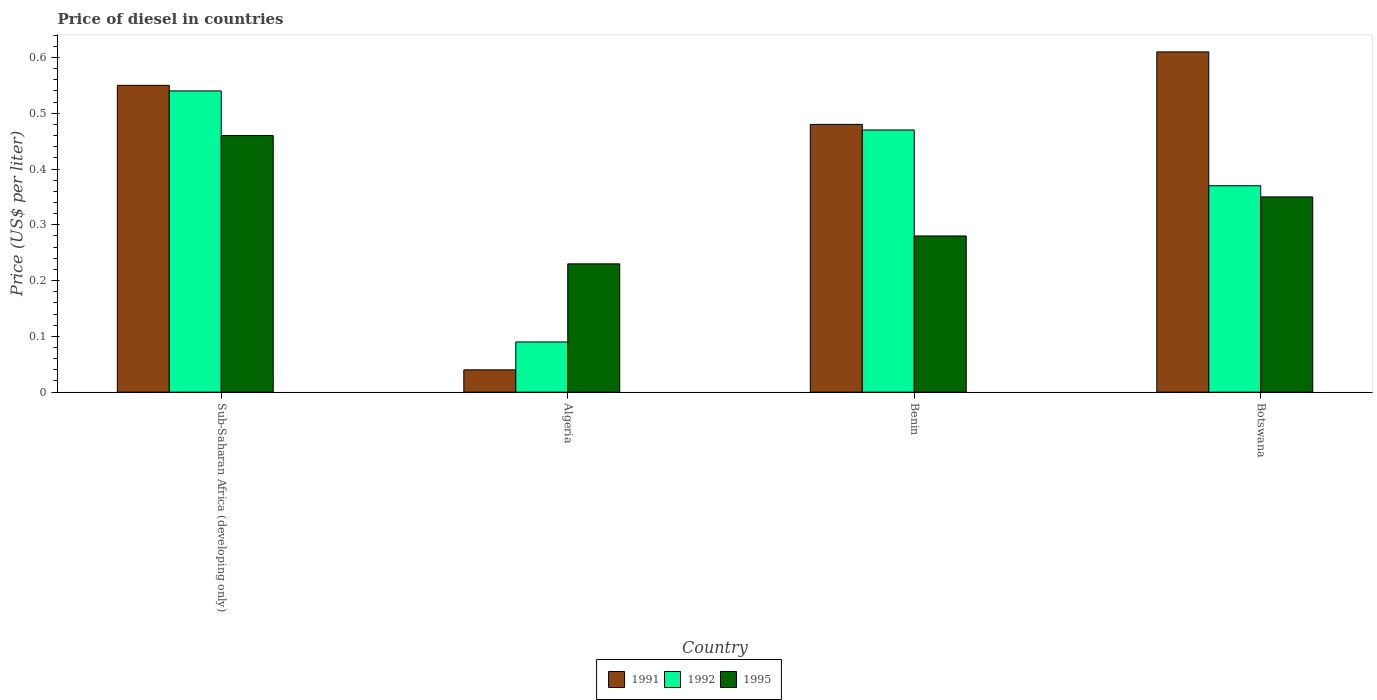How many groups of bars are there?
Ensure brevity in your answer.  4. Are the number of bars per tick equal to the number of legend labels?
Offer a terse response. Yes. Are the number of bars on each tick of the X-axis equal?
Your answer should be very brief. Yes. What is the label of the 2nd group of bars from the left?
Your response must be concise. Algeria. In how many cases, is the number of bars for a given country not equal to the number of legend labels?
Provide a succinct answer. 0. What is the price of diesel in 1992 in Sub-Saharan Africa (developing only)?
Your response must be concise. 0.54. Across all countries, what is the maximum price of diesel in 1991?
Your response must be concise. 0.61. In which country was the price of diesel in 1995 maximum?
Ensure brevity in your answer.  Sub-Saharan Africa (developing only). In which country was the price of diesel in 1992 minimum?
Offer a terse response. Algeria. What is the total price of diesel in 1991 in the graph?
Ensure brevity in your answer.  1.68. What is the difference between the price of diesel in 1992 in Algeria and that in Benin?
Make the answer very short. -0.38. What is the difference between the price of diesel in 1992 in Algeria and the price of diesel in 1991 in Sub-Saharan Africa (developing only)?
Offer a terse response. -0.46. What is the average price of diesel in 1991 per country?
Your answer should be compact. 0.42. What is the difference between the price of diesel of/in 1991 and price of diesel of/in 1992 in Sub-Saharan Africa (developing only)?
Provide a succinct answer. 0.01. What is the ratio of the price of diesel in 1991 in Algeria to that in Benin?
Your answer should be compact. 0.08. What is the difference between the highest and the second highest price of diesel in 1991?
Give a very brief answer. 0.06. What is the difference between the highest and the lowest price of diesel in 1992?
Offer a terse response. 0.45. Is the sum of the price of diesel in 1995 in Algeria and Benin greater than the maximum price of diesel in 1992 across all countries?
Keep it short and to the point. No. What does the 3rd bar from the left in Algeria represents?
Ensure brevity in your answer.  1995. What does the 2nd bar from the right in Botswana represents?
Keep it short and to the point. 1992. Is it the case that in every country, the sum of the price of diesel in 1991 and price of diesel in 1995 is greater than the price of diesel in 1992?
Keep it short and to the point. Yes. How many bars are there?
Make the answer very short. 12. Are all the bars in the graph horizontal?
Ensure brevity in your answer.  No. Are the values on the major ticks of Y-axis written in scientific E-notation?
Make the answer very short. No. Does the graph contain any zero values?
Provide a succinct answer. No. Does the graph contain grids?
Keep it short and to the point. No. Where does the legend appear in the graph?
Offer a very short reply. Bottom center. How many legend labels are there?
Ensure brevity in your answer.  3. What is the title of the graph?
Provide a short and direct response. Price of diesel in countries. Does "1998" appear as one of the legend labels in the graph?
Your response must be concise. No. What is the label or title of the X-axis?
Provide a short and direct response. Country. What is the label or title of the Y-axis?
Offer a very short reply. Price (US$ per liter). What is the Price (US$ per liter) of 1991 in Sub-Saharan Africa (developing only)?
Provide a short and direct response. 0.55. What is the Price (US$ per liter) of 1992 in Sub-Saharan Africa (developing only)?
Provide a short and direct response. 0.54. What is the Price (US$ per liter) of 1995 in Sub-Saharan Africa (developing only)?
Offer a terse response. 0.46. What is the Price (US$ per liter) in 1992 in Algeria?
Ensure brevity in your answer.  0.09. What is the Price (US$ per liter) of 1995 in Algeria?
Make the answer very short. 0.23. What is the Price (US$ per liter) in 1991 in Benin?
Ensure brevity in your answer.  0.48. What is the Price (US$ per liter) in 1992 in Benin?
Make the answer very short. 0.47. What is the Price (US$ per liter) in 1995 in Benin?
Provide a succinct answer. 0.28. What is the Price (US$ per liter) in 1991 in Botswana?
Ensure brevity in your answer.  0.61. What is the Price (US$ per liter) of 1992 in Botswana?
Your response must be concise. 0.37. What is the Price (US$ per liter) in 1995 in Botswana?
Your answer should be very brief. 0.35. Across all countries, what is the maximum Price (US$ per liter) of 1991?
Provide a short and direct response. 0.61. Across all countries, what is the maximum Price (US$ per liter) in 1992?
Your response must be concise. 0.54. Across all countries, what is the maximum Price (US$ per liter) of 1995?
Your answer should be compact. 0.46. Across all countries, what is the minimum Price (US$ per liter) in 1992?
Your answer should be very brief. 0.09. Across all countries, what is the minimum Price (US$ per liter) in 1995?
Keep it short and to the point. 0.23. What is the total Price (US$ per liter) of 1991 in the graph?
Keep it short and to the point. 1.68. What is the total Price (US$ per liter) in 1992 in the graph?
Give a very brief answer. 1.47. What is the total Price (US$ per liter) in 1995 in the graph?
Offer a terse response. 1.32. What is the difference between the Price (US$ per liter) of 1991 in Sub-Saharan Africa (developing only) and that in Algeria?
Give a very brief answer. 0.51. What is the difference between the Price (US$ per liter) of 1992 in Sub-Saharan Africa (developing only) and that in Algeria?
Provide a short and direct response. 0.45. What is the difference between the Price (US$ per liter) in 1995 in Sub-Saharan Africa (developing only) and that in Algeria?
Your response must be concise. 0.23. What is the difference between the Price (US$ per liter) in 1991 in Sub-Saharan Africa (developing only) and that in Benin?
Your response must be concise. 0.07. What is the difference between the Price (US$ per liter) of 1992 in Sub-Saharan Africa (developing only) and that in Benin?
Your answer should be compact. 0.07. What is the difference between the Price (US$ per liter) in 1995 in Sub-Saharan Africa (developing only) and that in Benin?
Your answer should be very brief. 0.18. What is the difference between the Price (US$ per liter) in 1991 in Sub-Saharan Africa (developing only) and that in Botswana?
Give a very brief answer. -0.06. What is the difference between the Price (US$ per liter) in 1992 in Sub-Saharan Africa (developing only) and that in Botswana?
Your response must be concise. 0.17. What is the difference between the Price (US$ per liter) of 1995 in Sub-Saharan Africa (developing only) and that in Botswana?
Ensure brevity in your answer.  0.11. What is the difference between the Price (US$ per liter) in 1991 in Algeria and that in Benin?
Ensure brevity in your answer.  -0.44. What is the difference between the Price (US$ per liter) in 1992 in Algeria and that in Benin?
Ensure brevity in your answer.  -0.38. What is the difference between the Price (US$ per liter) of 1995 in Algeria and that in Benin?
Keep it short and to the point. -0.05. What is the difference between the Price (US$ per liter) in 1991 in Algeria and that in Botswana?
Your response must be concise. -0.57. What is the difference between the Price (US$ per liter) of 1992 in Algeria and that in Botswana?
Ensure brevity in your answer.  -0.28. What is the difference between the Price (US$ per liter) in 1995 in Algeria and that in Botswana?
Provide a short and direct response. -0.12. What is the difference between the Price (US$ per liter) in 1991 in Benin and that in Botswana?
Your answer should be compact. -0.13. What is the difference between the Price (US$ per liter) in 1992 in Benin and that in Botswana?
Your response must be concise. 0.1. What is the difference between the Price (US$ per liter) in 1995 in Benin and that in Botswana?
Your answer should be very brief. -0.07. What is the difference between the Price (US$ per liter) in 1991 in Sub-Saharan Africa (developing only) and the Price (US$ per liter) in 1992 in Algeria?
Ensure brevity in your answer.  0.46. What is the difference between the Price (US$ per liter) of 1991 in Sub-Saharan Africa (developing only) and the Price (US$ per liter) of 1995 in Algeria?
Your response must be concise. 0.32. What is the difference between the Price (US$ per liter) in 1992 in Sub-Saharan Africa (developing only) and the Price (US$ per liter) in 1995 in Algeria?
Provide a short and direct response. 0.31. What is the difference between the Price (US$ per liter) in 1991 in Sub-Saharan Africa (developing only) and the Price (US$ per liter) in 1992 in Benin?
Your answer should be compact. 0.08. What is the difference between the Price (US$ per liter) of 1991 in Sub-Saharan Africa (developing only) and the Price (US$ per liter) of 1995 in Benin?
Offer a terse response. 0.27. What is the difference between the Price (US$ per liter) of 1992 in Sub-Saharan Africa (developing only) and the Price (US$ per liter) of 1995 in Benin?
Ensure brevity in your answer.  0.26. What is the difference between the Price (US$ per liter) in 1991 in Sub-Saharan Africa (developing only) and the Price (US$ per liter) in 1992 in Botswana?
Provide a succinct answer. 0.18. What is the difference between the Price (US$ per liter) of 1991 in Sub-Saharan Africa (developing only) and the Price (US$ per liter) of 1995 in Botswana?
Provide a succinct answer. 0.2. What is the difference between the Price (US$ per liter) of 1992 in Sub-Saharan Africa (developing only) and the Price (US$ per liter) of 1995 in Botswana?
Ensure brevity in your answer.  0.19. What is the difference between the Price (US$ per liter) in 1991 in Algeria and the Price (US$ per liter) in 1992 in Benin?
Your answer should be compact. -0.43. What is the difference between the Price (US$ per liter) of 1991 in Algeria and the Price (US$ per liter) of 1995 in Benin?
Ensure brevity in your answer.  -0.24. What is the difference between the Price (US$ per liter) in 1992 in Algeria and the Price (US$ per liter) in 1995 in Benin?
Give a very brief answer. -0.19. What is the difference between the Price (US$ per liter) in 1991 in Algeria and the Price (US$ per liter) in 1992 in Botswana?
Your answer should be compact. -0.33. What is the difference between the Price (US$ per liter) of 1991 in Algeria and the Price (US$ per liter) of 1995 in Botswana?
Provide a short and direct response. -0.31. What is the difference between the Price (US$ per liter) of 1992 in Algeria and the Price (US$ per liter) of 1995 in Botswana?
Provide a short and direct response. -0.26. What is the difference between the Price (US$ per liter) in 1991 in Benin and the Price (US$ per liter) in 1992 in Botswana?
Offer a terse response. 0.11. What is the difference between the Price (US$ per liter) in 1991 in Benin and the Price (US$ per liter) in 1995 in Botswana?
Keep it short and to the point. 0.13. What is the difference between the Price (US$ per liter) of 1992 in Benin and the Price (US$ per liter) of 1995 in Botswana?
Keep it short and to the point. 0.12. What is the average Price (US$ per liter) of 1991 per country?
Your answer should be very brief. 0.42. What is the average Price (US$ per liter) in 1992 per country?
Your answer should be compact. 0.37. What is the average Price (US$ per liter) of 1995 per country?
Ensure brevity in your answer.  0.33. What is the difference between the Price (US$ per liter) of 1991 and Price (US$ per liter) of 1992 in Sub-Saharan Africa (developing only)?
Your answer should be very brief. 0.01. What is the difference between the Price (US$ per liter) of 1991 and Price (US$ per liter) of 1995 in Sub-Saharan Africa (developing only)?
Make the answer very short. 0.09. What is the difference between the Price (US$ per liter) of 1991 and Price (US$ per liter) of 1995 in Algeria?
Offer a very short reply. -0.19. What is the difference between the Price (US$ per liter) in 1992 and Price (US$ per liter) in 1995 in Algeria?
Your response must be concise. -0.14. What is the difference between the Price (US$ per liter) of 1992 and Price (US$ per liter) of 1995 in Benin?
Your response must be concise. 0.19. What is the difference between the Price (US$ per liter) of 1991 and Price (US$ per liter) of 1992 in Botswana?
Your answer should be compact. 0.24. What is the difference between the Price (US$ per liter) in 1991 and Price (US$ per liter) in 1995 in Botswana?
Ensure brevity in your answer.  0.26. What is the difference between the Price (US$ per liter) of 1992 and Price (US$ per liter) of 1995 in Botswana?
Provide a short and direct response. 0.02. What is the ratio of the Price (US$ per liter) of 1991 in Sub-Saharan Africa (developing only) to that in Algeria?
Give a very brief answer. 13.75. What is the ratio of the Price (US$ per liter) in 1992 in Sub-Saharan Africa (developing only) to that in Algeria?
Make the answer very short. 6. What is the ratio of the Price (US$ per liter) of 1995 in Sub-Saharan Africa (developing only) to that in Algeria?
Your response must be concise. 2. What is the ratio of the Price (US$ per liter) of 1991 in Sub-Saharan Africa (developing only) to that in Benin?
Make the answer very short. 1.15. What is the ratio of the Price (US$ per liter) in 1992 in Sub-Saharan Africa (developing only) to that in Benin?
Your answer should be compact. 1.15. What is the ratio of the Price (US$ per liter) of 1995 in Sub-Saharan Africa (developing only) to that in Benin?
Provide a short and direct response. 1.64. What is the ratio of the Price (US$ per liter) in 1991 in Sub-Saharan Africa (developing only) to that in Botswana?
Keep it short and to the point. 0.9. What is the ratio of the Price (US$ per liter) in 1992 in Sub-Saharan Africa (developing only) to that in Botswana?
Your answer should be very brief. 1.46. What is the ratio of the Price (US$ per liter) in 1995 in Sub-Saharan Africa (developing only) to that in Botswana?
Make the answer very short. 1.31. What is the ratio of the Price (US$ per liter) in 1991 in Algeria to that in Benin?
Ensure brevity in your answer.  0.08. What is the ratio of the Price (US$ per liter) of 1992 in Algeria to that in Benin?
Give a very brief answer. 0.19. What is the ratio of the Price (US$ per liter) of 1995 in Algeria to that in Benin?
Keep it short and to the point. 0.82. What is the ratio of the Price (US$ per liter) of 1991 in Algeria to that in Botswana?
Provide a short and direct response. 0.07. What is the ratio of the Price (US$ per liter) in 1992 in Algeria to that in Botswana?
Make the answer very short. 0.24. What is the ratio of the Price (US$ per liter) of 1995 in Algeria to that in Botswana?
Provide a short and direct response. 0.66. What is the ratio of the Price (US$ per liter) of 1991 in Benin to that in Botswana?
Your answer should be very brief. 0.79. What is the ratio of the Price (US$ per liter) in 1992 in Benin to that in Botswana?
Make the answer very short. 1.27. What is the ratio of the Price (US$ per liter) of 1995 in Benin to that in Botswana?
Keep it short and to the point. 0.8. What is the difference between the highest and the second highest Price (US$ per liter) of 1991?
Give a very brief answer. 0.06. What is the difference between the highest and the second highest Price (US$ per liter) of 1992?
Your answer should be compact. 0.07. What is the difference between the highest and the second highest Price (US$ per liter) of 1995?
Ensure brevity in your answer.  0.11. What is the difference between the highest and the lowest Price (US$ per liter) of 1991?
Ensure brevity in your answer.  0.57. What is the difference between the highest and the lowest Price (US$ per liter) in 1992?
Give a very brief answer. 0.45. What is the difference between the highest and the lowest Price (US$ per liter) in 1995?
Offer a terse response. 0.23. 